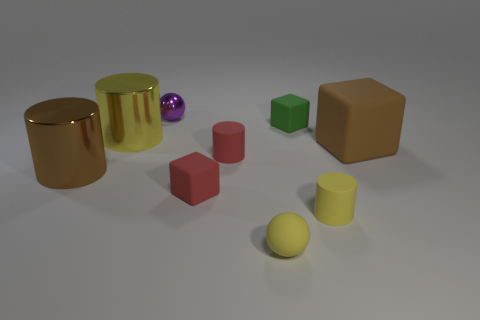Subtract all cyan cubes. How many yellow cylinders are left? 2 Subtract all tiny matte blocks. How many blocks are left? 1 Subtract 2 cylinders. How many cylinders are left? 2 Subtract all yellow cubes. Subtract all brown cylinders. How many cubes are left? 3 Subtract all spheres. How many objects are left? 7 Subtract all big yellow cylinders. Subtract all yellow shiny objects. How many objects are left? 7 Add 7 matte cylinders. How many matte cylinders are left? 9 Add 7 large red metal cylinders. How many large red metal cylinders exist? 7 Subtract 0 green balls. How many objects are left? 9 